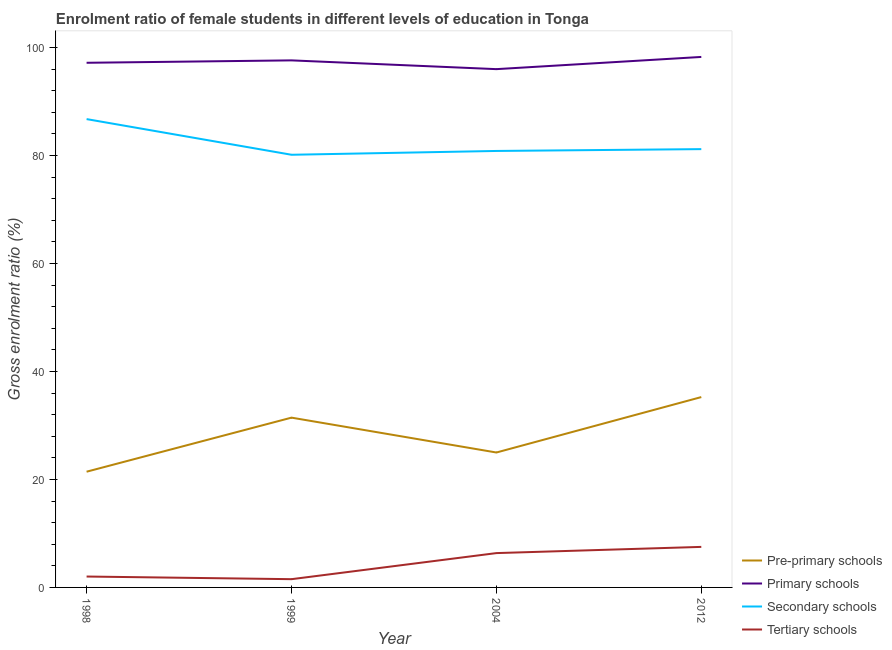How many different coloured lines are there?
Ensure brevity in your answer.  4. Does the line corresponding to gross enrolment ratio(male) in primary schools intersect with the line corresponding to gross enrolment ratio(male) in tertiary schools?
Give a very brief answer. No. What is the gross enrolment ratio(male) in secondary schools in 2004?
Give a very brief answer. 80.84. Across all years, what is the maximum gross enrolment ratio(male) in tertiary schools?
Keep it short and to the point. 7.51. Across all years, what is the minimum gross enrolment ratio(male) in secondary schools?
Your answer should be compact. 80.14. What is the total gross enrolment ratio(male) in tertiary schools in the graph?
Ensure brevity in your answer.  17.41. What is the difference between the gross enrolment ratio(male) in primary schools in 1999 and that in 2012?
Your response must be concise. -0.64. What is the difference between the gross enrolment ratio(male) in tertiary schools in 2004 and the gross enrolment ratio(male) in primary schools in 2012?
Give a very brief answer. -91.9. What is the average gross enrolment ratio(male) in secondary schools per year?
Your answer should be very brief. 82.23. In the year 1999, what is the difference between the gross enrolment ratio(male) in secondary schools and gross enrolment ratio(male) in primary schools?
Give a very brief answer. -17.48. In how many years, is the gross enrolment ratio(male) in secondary schools greater than 76 %?
Provide a short and direct response. 4. What is the ratio of the gross enrolment ratio(male) in tertiary schools in 1998 to that in 1999?
Offer a terse response. 1.32. Is the difference between the gross enrolment ratio(male) in secondary schools in 1998 and 1999 greater than the difference between the gross enrolment ratio(male) in tertiary schools in 1998 and 1999?
Provide a short and direct response. Yes. What is the difference between the highest and the second highest gross enrolment ratio(male) in secondary schools?
Give a very brief answer. 5.56. What is the difference between the highest and the lowest gross enrolment ratio(male) in secondary schools?
Make the answer very short. 6.6. Is the sum of the gross enrolment ratio(male) in secondary schools in 1999 and 2004 greater than the maximum gross enrolment ratio(male) in primary schools across all years?
Your answer should be compact. Yes. Is it the case that in every year, the sum of the gross enrolment ratio(male) in pre-primary schools and gross enrolment ratio(male) in primary schools is greater than the sum of gross enrolment ratio(male) in tertiary schools and gross enrolment ratio(male) in secondary schools?
Ensure brevity in your answer.  Yes. Are the values on the major ticks of Y-axis written in scientific E-notation?
Provide a succinct answer. No. Does the graph contain grids?
Ensure brevity in your answer.  No. How many legend labels are there?
Your answer should be compact. 4. What is the title of the graph?
Ensure brevity in your answer.  Enrolment ratio of female students in different levels of education in Tonga. Does "Burnt food" appear as one of the legend labels in the graph?
Offer a terse response. No. What is the label or title of the X-axis?
Keep it short and to the point. Year. What is the label or title of the Y-axis?
Your answer should be compact. Gross enrolment ratio (%). What is the Gross enrolment ratio (%) in Pre-primary schools in 1998?
Ensure brevity in your answer.  21.43. What is the Gross enrolment ratio (%) of Primary schools in 1998?
Give a very brief answer. 97.17. What is the Gross enrolment ratio (%) in Secondary schools in 1998?
Your answer should be very brief. 86.74. What is the Gross enrolment ratio (%) in Tertiary schools in 1998?
Give a very brief answer. 2.02. What is the Gross enrolment ratio (%) of Pre-primary schools in 1999?
Your answer should be compact. 31.45. What is the Gross enrolment ratio (%) of Primary schools in 1999?
Your answer should be compact. 97.62. What is the Gross enrolment ratio (%) in Secondary schools in 1999?
Your answer should be compact. 80.14. What is the Gross enrolment ratio (%) in Tertiary schools in 1999?
Your answer should be compact. 1.53. What is the Gross enrolment ratio (%) of Pre-primary schools in 2004?
Ensure brevity in your answer.  24.99. What is the Gross enrolment ratio (%) of Primary schools in 2004?
Keep it short and to the point. 96. What is the Gross enrolment ratio (%) in Secondary schools in 2004?
Make the answer very short. 80.84. What is the Gross enrolment ratio (%) of Tertiary schools in 2004?
Ensure brevity in your answer.  6.36. What is the Gross enrolment ratio (%) in Pre-primary schools in 2012?
Provide a succinct answer. 35.26. What is the Gross enrolment ratio (%) in Primary schools in 2012?
Your answer should be compact. 98.26. What is the Gross enrolment ratio (%) of Secondary schools in 2012?
Provide a short and direct response. 81.18. What is the Gross enrolment ratio (%) in Tertiary schools in 2012?
Provide a short and direct response. 7.51. Across all years, what is the maximum Gross enrolment ratio (%) in Pre-primary schools?
Ensure brevity in your answer.  35.26. Across all years, what is the maximum Gross enrolment ratio (%) in Primary schools?
Offer a terse response. 98.26. Across all years, what is the maximum Gross enrolment ratio (%) in Secondary schools?
Ensure brevity in your answer.  86.74. Across all years, what is the maximum Gross enrolment ratio (%) of Tertiary schools?
Ensure brevity in your answer.  7.51. Across all years, what is the minimum Gross enrolment ratio (%) in Pre-primary schools?
Offer a terse response. 21.43. Across all years, what is the minimum Gross enrolment ratio (%) of Primary schools?
Offer a very short reply. 96. Across all years, what is the minimum Gross enrolment ratio (%) in Secondary schools?
Provide a succinct answer. 80.14. Across all years, what is the minimum Gross enrolment ratio (%) of Tertiary schools?
Your response must be concise. 1.53. What is the total Gross enrolment ratio (%) in Pre-primary schools in the graph?
Give a very brief answer. 113.13. What is the total Gross enrolment ratio (%) of Primary schools in the graph?
Your answer should be compact. 389.05. What is the total Gross enrolment ratio (%) in Secondary schools in the graph?
Your answer should be compact. 328.91. What is the total Gross enrolment ratio (%) in Tertiary schools in the graph?
Your response must be concise. 17.41. What is the difference between the Gross enrolment ratio (%) of Pre-primary schools in 1998 and that in 1999?
Provide a short and direct response. -10.01. What is the difference between the Gross enrolment ratio (%) in Primary schools in 1998 and that in 1999?
Provide a succinct answer. -0.45. What is the difference between the Gross enrolment ratio (%) in Secondary schools in 1998 and that in 1999?
Offer a very short reply. 6.6. What is the difference between the Gross enrolment ratio (%) of Tertiary schools in 1998 and that in 1999?
Offer a terse response. 0.49. What is the difference between the Gross enrolment ratio (%) in Pre-primary schools in 1998 and that in 2004?
Your answer should be very brief. -3.56. What is the difference between the Gross enrolment ratio (%) in Primary schools in 1998 and that in 2004?
Your response must be concise. 1.18. What is the difference between the Gross enrolment ratio (%) in Secondary schools in 1998 and that in 2004?
Your response must be concise. 5.9. What is the difference between the Gross enrolment ratio (%) of Tertiary schools in 1998 and that in 2004?
Your answer should be compact. -4.34. What is the difference between the Gross enrolment ratio (%) in Pre-primary schools in 1998 and that in 2012?
Give a very brief answer. -13.82. What is the difference between the Gross enrolment ratio (%) in Primary schools in 1998 and that in 2012?
Your response must be concise. -1.08. What is the difference between the Gross enrolment ratio (%) in Secondary schools in 1998 and that in 2012?
Keep it short and to the point. 5.56. What is the difference between the Gross enrolment ratio (%) of Tertiary schools in 1998 and that in 2012?
Provide a short and direct response. -5.49. What is the difference between the Gross enrolment ratio (%) of Pre-primary schools in 1999 and that in 2004?
Keep it short and to the point. 6.46. What is the difference between the Gross enrolment ratio (%) in Primary schools in 1999 and that in 2004?
Make the answer very short. 1.62. What is the difference between the Gross enrolment ratio (%) of Secondary schools in 1999 and that in 2004?
Offer a terse response. -0.7. What is the difference between the Gross enrolment ratio (%) of Tertiary schools in 1999 and that in 2004?
Ensure brevity in your answer.  -4.83. What is the difference between the Gross enrolment ratio (%) of Pre-primary schools in 1999 and that in 2012?
Your response must be concise. -3.81. What is the difference between the Gross enrolment ratio (%) of Primary schools in 1999 and that in 2012?
Give a very brief answer. -0.64. What is the difference between the Gross enrolment ratio (%) in Secondary schools in 1999 and that in 2012?
Keep it short and to the point. -1.04. What is the difference between the Gross enrolment ratio (%) in Tertiary schools in 1999 and that in 2012?
Your answer should be very brief. -5.98. What is the difference between the Gross enrolment ratio (%) in Pre-primary schools in 2004 and that in 2012?
Offer a very short reply. -10.27. What is the difference between the Gross enrolment ratio (%) in Primary schools in 2004 and that in 2012?
Your answer should be very brief. -2.26. What is the difference between the Gross enrolment ratio (%) in Secondary schools in 2004 and that in 2012?
Offer a terse response. -0.34. What is the difference between the Gross enrolment ratio (%) in Tertiary schools in 2004 and that in 2012?
Your answer should be very brief. -1.15. What is the difference between the Gross enrolment ratio (%) in Pre-primary schools in 1998 and the Gross enrolment ratio (%) in Primary schools in 1999?
Give a very brief answer. -76.19. What is the difference between the Gross enrolment ratio (%) in Pre-primary schools in 1998 and the Gross enrolment ratio (%) in Secondary schools in 1999?
Your response must be concise. -58.7. What is the difference between the Gross enrolment ratio (%) of Pre-primary schools in 1998 and the Gross enrolment ratio (%) of Tertiary schools in 1999?
Provide a succinct answer. 19.91. What is the difference between the Gross enrolment ratio (%) of Primary schools in 1998 and the Gross enrolment ratio (%) of Secondary schools in 1999?
Ensure brevity in your answer.  17.04. What is the difference between the Gross enrolment ratio (%) in Primary schools in 1998 and the Gross enrolment ratio (%) in Tertiary schools in 1999?
Offer a terse response. 95.65. What is the difference between the Gross enrolment ratio (%) in Secondary schools in 1998 and the Gross enrolment ratio (%) in Tertiary schools in 1999?
Your response must be concise. 85.22. What is the difference between the Gross enrolment ratio (%) in Pre-primary schools in 1998 and the Gross enrolment ratio (%) in Primary schools in 2004?
Keep it short and to the point. -74.56. What is the difference between the Gross enrolment ratio (%) in Pre-primary schools in 1998 and the Gross enrolment ratio (%) in Secondary schools in 2004?
Provide a succinct answer. -59.41. What is the difference between the Gross enrolment ratio (%) of Pre-primary schools in 1998 and the Gross enrolment ratio (%) of Tertiary schools in 2004?
Make the answer very short. 15.08. What is the difference between the Gross enrolment ratio (%) of Primary schools in 1998 and the Gross enrolment ratio (%) of Secondary schools in 2004?
Offer a terse response. 16.33. What is the difference between the Gross enrolment ratio (%) in Primary schools in 1998 and the Gross enrolment ratio (%) in Tertiary schools in 2004?
Your answer should be compact. 90.82. What is the difference between the Gross enrolment ratio (%) of Secondary schools in 1998 and the Gross enrolment ratio (%) of Tertiary schools in 2004?
Your answer should be very brief. 80.39. What is the difference between the Gross enrolment ratio (%) in Pre-primary schools in 1998 and the Gross enrolment ratio (%) in Primary schools in 2012?
Offer a very short reply. -76.82. What is the difference between the Gross enrolment ratio (%) in Pre-primary schools in 1998 and the Gross enrolment ratio (%) in Secondary schools in 2012?
Your answer should be very brief. -59.75. What is the difference between the Gross enrolment ratio (%) in Pre-primary schools in 1998 and the Gross enrolment ratio (%) in Tertiary schools in 2012?
Provide a short and direct response. 13.92. What is the difference between the Gross enrolment ratio (%) of Primary schools in 1998 and the Gross enrolment ratio (%) of Secondary schools in 2012?
Offer a very short reply. 15.99. What is the difference between the Gross enrolment ratio (%) in Primary schools in 1998 and the Gross enrolment ratio (%) in Tertiary schools in 2012?
Keep it short and to the point. 89.66. What is the difference between the Gross enrolment ratio (%) in Secondary schools in 1998 and the Gross enrolment ratio (%) in Tertiary schools in 2012?
Offer a terse response. 79.23. What is the difference between the Gross enrolment ratio (%) of Pre-primary schools in 1999 and the Gross enrolment ratio (%) of Primary schools in 2004?
Offer a terse response. -64.55. What is the difference between the Gross enrolment ratio (%) of Pre-primary schools in 1999 and the Gross enrolment ratio (%) of Secondary schools in 2004?
Ensure brevity in your answer.  -49.39. What is the difference between the Gross enrolment ratio (%) in Pre-primary schools in 1999 and the Gross enrolment ratio (%) in Tertiary schools in 2004?
Give a very brief answer. 25.09. What is the difference between the Gross enrolment ratio (%) of Primary schools in 1999 and the Gross enrolment ratio (%) of Secondary schools in 2004?
Ensure brevity in your answer.  16.78. What is the difference between the Gross enrolment ratio (%) of Primary schools in 1999 and the Gross enrolment ratio (%) of Tertiary schools in 2004?
Your answer should be compact. 91.26. What is the difference between the Gross enrolment ratio (%) of Secondary schools in 1999 and the Gross enrolment ratio (%) of Tertiary schools in 2004?
Keep it short and to the point. 73.78. What is the difference between the Gross enrolment ratio (%) in Pre-primary schools in 1999 and the Gross enrolment ratio (%) in Primary schools in 2012?
Your answer should be compact. -66.81. What is the difference between the Gross enrolment ratio (%) of Pre-primary schools in 1999 and the Gross enrolment ratio (%) of Secondary schools in 2012?
Give a very brief answer. -49.73. What is the difference between the Gross enrolment ratio (%) in Pre-primary schools in 1999 and the Gross enrolment ratio (%) in Tertiary schools in 2012?
Give a very brief answer. 23.94. What is the difference between the Gross enrolment ratio (%) in Primary schools in 1999 and the Gross enrolment ratio (%) in Secondary schools in 2012?
Your answer should be compact. 16.44. What is the difference between the Gross enrolment ratio (%) in Primary schools in 1999 and the Gross enrolment ratio (%) in Tertiary schools in 2012?
Offer a very short reply. 90.11. What is the difference between the Gross enrolment ratio (%) in Secondary schools in 1999 and the Gross enrolment ratio (%) in Tertiary schools in 2012?
Your answer should be compact. 72.63. What is the difference between the Gross enrolment ratio (%) in Pre-primary schools in 2004 and the Gross enrolment ratio (%) in Primary schools in 2012?
Your answer should be very brief. -73.27. What is the difference between the Gross enrolment ratio (%) of Pre-primary schools in 2004 and the Gross enrolment ratio (%) of Secondary schools in 2012?
Your response must be concise. -56.19. What is the difference between the Gross enrolment ratio (%) in Pre-primary schools in 2004 and the Gross enrolment ratio (%) in Tertiary schools in 2012?
Offer a very short reply. 17.48. What is the difference between the Gross enrolment ratio (%) of Primary schools in 2004 and the Gross enrolment ratio (%) of Secondary schools in 2012?
Provide a succinct answer. 14.82. What is the difference between the Gross enrolment ratio (%) of Primary schools in 2004 and the Gross enrolment ratio (%) of Tertiary schools in 2012?
Provide a succinct answer. 88.49. What is the difference between the Gross enrolment ratio (%) in Secondary schools in 2004 and the Gross enrolment ratio (%) in Tertiary schools in 2012?
Offer a terse response. 73.33. What is the average Gross enrolment ratio (%) in Pre-primary schools per year?
Offer a terse response. 28.28. What is the average Gross enrolment ratio (%) of Primary schools per year?
Offer a terse response. 97.26. What is the average Gross enrolment ratio (%) in Secondary schools per year?
Provide a short and direct response. 82.23. What is the average Gross enrolment ratio (%) of Tertiary schools per year?
Ensure brevity in your answer.  4.35. In the year 1998, what is the difference between the Gross enrolment ratio (%) in Pre-primary schools and Gross enrolment ratio (%) in Primary schools?
Offer a terse response. -75.74. In the year 1998, what is the difference between the Gross enrolment ratio (%) in Pre-primary schools and Gross enrolment ratio (%) in Secondary schools?
Offer a terse response. -65.31. In the year 1998, what is the difference between the Gross enrolment ratio (%) of Pre-primary schools and Gross enrolment ratio (%) of Tertiary schools?
Keep it short and to the point. 19.42. In the year 1998, what is the difference between the Gross enrolment ratio (%) in Primary schools and Gross enrolment ratio (%) in Secondary schools?
Your answer should be very brief. 10.43. In the year 1998, what is the difference between the Gross enrolment ratio (%) in Primary schools and Gross enrolment ratio (%) in Tertiary schools?
Provide a short and direct response. 95.16. In the year 1998, what is the difference between the Gross enrolment ratio (%) of Secondary schools and Gross enrolment ratio (%) of Tertiary schools?
Ensure brevity in your answer.  84.72. In the year 1999, what is the difference between the Gross enrolment ratio (%) of Pre-primary schools and Gross enrolment ratio (%) of Primary schools?
Your answer should be very brief. -66.17. In the year 1999, what is the difference between the Gross enrolment ratio (%) of Pre-primary schools and Gross enrolment ratio (%) of Secondary schools?
Make the answer very short. -48.69. In the year 1999, what is the difference between the Gross enrolment ratio (%) of Pre-primary schools and Gross enrolment ratio (%) of Tertiary schools?
Offer a very short reply. 29.92. In the year 1999, what is the difference between the Gross enrolment ratio (%) in Primary schools and Gross enrolment ratio (%) in Secondary schools?
Offer a terse response. 17.48. In the year 1999, what is the difference between the Gross enrolment ratio (%) in Primary schools and Gross enrolment ratio (%) in Tertiary schools?
Your answer should be compact. 96.09. In the year 1999, what is the difference between the Gross enrolment ratio (%) in Secondary schools and Gross enrolment ratio (%) in Tertiary schools?
Provide a succinct answer. 78.61. In the year 2004, what is the difference between the Gross enrolment ratio (%) in Pre-primary schools and Gross enrolment ratio (%) in Primary schools?
Keep it short and to the point. -71.01. In the year 2004, what is the difference between the Gross enrolment ratio (%) in Pre-primary schools and Gross enrolment ratio (%) in Secondary schools?
Offer a terse response. -55.85. In the year 2004, what is the difference between the Gross enrolment ratio (%) in Pre-primary schools and Gross enrolment ratio (%) in Tertiary schools?
Offer a terse response. 18.63. In the year 2004, what is the difference between the Gross enrolment ratio (%) of Primary schools and Gross enrolment ratio (%) of Secondary schools?
Provide a short and direct response. 15.15. In the year 2004, what is the difference between the Gross enrolment ratio (%) of Primary schools and Gross enrolment ratio (%) of Tertiary schools?
Offer a very short reply. 89.64. In the year 2004, what is the difference between the Gross enrolment ratio (%) in Secondary schools and Gross enrolment ratio (%) in Tertiary schools?
Your answer should be compact. 74.48. In the year 2012, what is the difference between the Gross enrolment ratio (%) of Pre-primary schools and Gross enrolment ratio (%) of Primary schools?
Make the answer very short. -63. In the year 2012, what is the difference between the Gross enrolment ratio (%) of Pre-primary schools and Gross enrolment ratio (%) of Secondary schools?
Keep it short and to the point. -45.93. In the year 2012, what is the difference between the Gross enrolment ratio (%) of Pre-primary schools and Gross enrolment ratio (%) of Tertiary schools?
Give a very brief answer. 27.75. In the year 2012, what is the difference between the Gross enrolment ratio (%) of Primary schools and Gross enrolment ratio (%) of Secondary schools?
Make the answer very short. 17.07. In the year 2012, what is the difference between the Gross enrolment ratio (%) of Primary schools and Gross enrolment ratio (%) of Tertiary schools?
Ensure brevity in your answer.  90.75. In the year 2012, what is the difference between the Gross enrolment ratio (%) in Secondary schools and Gross enrolment ratio (%) in Tertiary schools?
Offer a very short reply. 73.67. What is the ratio of the Gross enrolment ratio (%) in Pre-primary schools in 1998 to that in 1999?
Offer a very short reply. 0.68. What is the ratio of the Gross enrolment ratio (%) of Secondary schools in 1998 to that in 1999?
Keep it short and to the point. 1.08. What is the ratio of the Gross enrolment ratio (%) of Tertiary schools in 1998 to that in 1999?
Keep it short and to the point. 1.32. What is the ratio of the Gross enrolment ratio (%) of Pre-primary schools in 1998 to that in 2004?
Provide a succinct answer. 0.86. What is the ratio of the Gross enrolment ratio (%) of Primary schools in 1998 to that in 2004?
Your answer should be compact. 1.01. What is the ratio of the Gross enrolment ratio (%) of Secondary schools in 1998 to that in 2004?
Offer a very short reply. 1.07. What is the ratio of the Gross enrolment ratio (%) in Tertiary schools in 1998 to that in 2004?
Your answer should be compact. 0.32. What is the ratio of the Gross enrolment ratio (%) of Pre-primary schools in 1998 to that in 2012?
Your response must be concise. 0.61. What is the ratio of the Gross enrolment ratio (%) in Primary schools in 1998 to that in 2012?
Offer a very short reply. 0.99. What is the ratio of the Gross enrolment ratio (%) in Secondary schools in 1998 to that in 2012?
Give a very brief answer. 1.07. What is the ratio of the Gross enrolment ratio (%) of Tertiary schools in 1998 to that in 2012?
Provide a succinct answer. 0.27. What is the ratio of the Gross enrolment ratio (%) of Pre-primary schools in 1999 to that in 2004?
Make the answer very short. 1.26. What is the ratio of the Gross enrolment ratio (%) of Primary schools in 1999 to that in 2004?
Make the answer very short. 1.02. What is the ratio of the Gross enrolment ratio (%) of Tertiary schools in 1999 to that in 2004?
Ensure brevity in your answer.  0.24. What is the ratio of the Gross enrolment ratio (%) of Pre-primary schools in 1999 to that in 2012?
Provide a succinct answer. 0.89. What is the ratio of the Gross enrolment ratio (%) in Secondary schools in 1999 to that in 2012?
Offer a terse response. 0.99. What is the ratio of the Gross enrolment ratio (%) of Tertiary schools in 1999 to that in 2012?
Keep it short and to the point. 0.2. What is the ratio of the Gross enrolment ratio (%) of Pre-primary schools in 2004 to that in 2012?
Give a very brief answer. 0.71. What is the ratio of the Gross enrolment ratio (%) of Primary schools in 2004 to that in 2012?
Give a very brief answer. 0.98. What is the ratio of the Gross enrolment ratio (%) in Tertiary schools in 2004 to that in 2012?
Your answer should be very brief. 0.85. What is the difference between the highest and the second highest Gross enrolment ratio (%) in Pre-primary schools?
Give a very brief answer. 3.81. What is the difference between the highest and the second highest Gross enrolment ratio (%) in Primary schools?
Ensure brevity in your answer.  0.64. What is the difference between the highest and the second highest Gross enrolment ratio (%) of Secondary schools?
Your response must be concise. 5.56. What is the difference between the highest and the second highest Gross enrolment ratio (%) of Tertiary schools?
Keep it short and to the point. 1.15. What is the difference between the highest and the lowest Gross enrolment ratio (%) in Pre-primary schools?
Ensure brevity in your answer.  13.82. What is the difference between the highest and the lowest Gross enrolment ratio (%) of Primary schools?
Keep it short and to the point. 2.26. What is the difference between the highest and the lowest Gross enrolment ratio (%) of Secondary schools?
Make the answer very short. 6.6. What is the difference between the highest and the lowest Gross enrolment ratio (%) in Tertiary schools?
Your answer should be very brief. 5.98. 